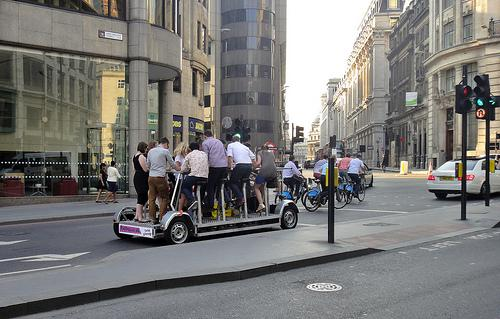Name the chief subject in the image and indicate the influence it has on adjacent factors. The central theme is a pedal-powered streetcar, setting the tone for cyclists and pedestrians to engage with one another. Tell us the highlight of the picture and its association with other constituents. A fun-filled streetcar experience overlaps with the lively street scene of cyclists and chatty pedestrians. Specify the prominent feature in the image and its relationship with other subjects. The bustling streetcar with enthusiastic passengers is connected to the street activity of cyclists and walkers. Briefly describe the main action in the photograph and link it to secondary elements. People are enjoying a streetcar ride, while nearby cyclists pedal and pedestrians stroll down the sidewalk. Mention the central scene in the image and its related components. Several individuals are cycling down the street beside a white car driving and pedestrians chatting on the sidewalk. State the primary focus in the image and its connection to the surroundings. The peddle-powered streetcar carrying people is the focal point, with cyclists and pedestrians in the vicinity. Identify the primary object and activity in the image. A group of people on a pedal-powered streetcar, engaging in conversation and sightseeing. Describe the predominant elements and interactions in the picture. Cyclists, pedestrians, and white cars occupy the street while people on a peddle-powered streetcar make conversation. What is catching the most attention in the image and how do other objects relate to it? A pedal-powered streetcar draws attention with people interacting, surrounded by cyclists, pedestrians, and white cars. What are the primary components and events in the image, and how are they linked? The main elements include a lively streetcar, cyclists, and walkers, creating a bustling and energetic atmosphere. Are there any animals in the glass building in the background at X:0 Y:5 Width:203 Height:203? No, it's not mentioned in the image. Can you identify the black and yellow banner hanging at X:400 Y:91 Width:19 Height:19? There is a white and green banner in the image, not a black and yellow banner. This instruction is misleading because it gives wrong information about the color of the banner. Can you find the orange stoplight at X:452 Y:81 Width:20 Height:20? There is a stoplight in the image, but it is not orange. The instruction is misleading because it gives incorrect information about the color of the stoplight. The sky in the image is cloudy and dark at X:302 Y:19 Width:32 Height:32. The instruction is misleading because it provides incorrect information about the sky. It does not mention the specific state of the sky in the given position. Are all the bicycles red in color at X:274 Y:135 Width:114 Height:114? The instruction is misleading because it assumes that all bicycles in the image are red, which is not mentioned in the given information. Do all the people in the image wear orange shirts at X:93 Y:158 Width:27 Height:27? The instruction is misleading because there are not all people in the image wearing orange shirts. There might be a man wearing a purple shirt, but not everyone is wearing orange. There is a blue car driving at X:422 Y:132 Width:77 Height:77. The instruction is misleading because there is a white car driving in the image, not a blue car. The information about the color of the car is incorrect. Do you see the white paint with blue stripes at X:0 Y:237 Width:105 Height:105? The instruction is misleading because it gives false information regarding a white paint. There is white paint, but it does not have blue stripes. 